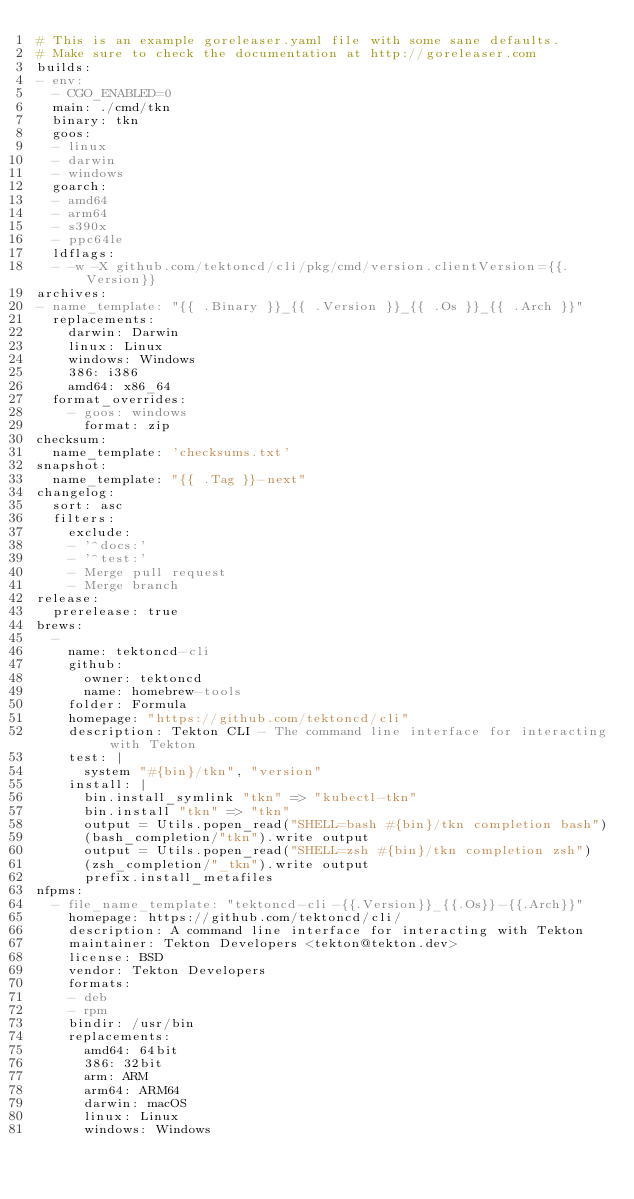<code> <loc_0><loc_0><loc_500><loc_500><_YAML_># This is an example goreleaser.yaml file with some sane defaults.
# Make sure to check the documentation at http://goreleaser.com
builds:
- env:
  - CGO_ENABLED=0
  main: ./cmd/tkn
  binary: tkn
  goos:
  - linux
  - darwin
  - windows
  goarch:
  - amd64
  - arm64
  - s390x
  - ppc64le
  ldflags:
  - -w -X github.com/tektoncd/cli/pkg/cmd/version.clientVersion={{.Version}}
archives:
- name_template: "{{ .Binary }}_{{ .Version }}_{{ .Os }}_{{ .Arch }}"
  replacements:
    darwin: Darwin
    linux: Linux
    windows: Windows
    386: i386
    amd64: x86_64
  format_overrides:
    - goos: windows
      format: zip
checksum:
  name_template: 'checksums.txt'
snapshot:
  name_template: "{{ .Tag }}-next"
changelog:
  sort: asc
  filters:
    exclude:
    - '^docs:'
    - '^test:'
    - Merge pull request
    - Merge branch
release:
  prerelease: true
brews:
  -
    name: tektoncd-cli
    github:
      owner: tektoncd
      name: homebrew-tools
    folder: Formula
    homepage: "https://github.com/tektoncd/cli"
    description: Tekton CLI - The command line interface for interacting with Tekton
    test: |
      system "#{bin}/tkn", "version"
    install: |
      bin.install_symlink "tkn" => "kubectl-tkn"
      bin.install "tkn" => "tkn"
      output = Utils.popen_read("SHELL=bash #{bin}/tkn completion bash")
      (bash_completion/"tkn").write output
      output = Utils.popen_read("SHELL=zsh #{bin}/tkn completion zsh")
      (zsh_completion/"_tkn").write output
      prefix.install_metafiles
nfpms:
  - file_name_template: "tektoncd-cli-{{.Version}}_{{.Os}}-{{.Arch}}"
    homepage: https://github.com/tektoncd/cli/
    description: A command line interface for interacting with Tekton
    maintainer: Tekton Developers <tekton@tekton.dev>
    license: BSD
    vendor: Tekton Developers
    formats:
    - deb
    - rpm
    bindir: /usr/bin
    replacements:
      amd64: 64bit
      386: 32bit
      arm: ARM
      arm64: ARM64
      darwin: macOS
      linux: Linux
      windows: Windows
</code> 